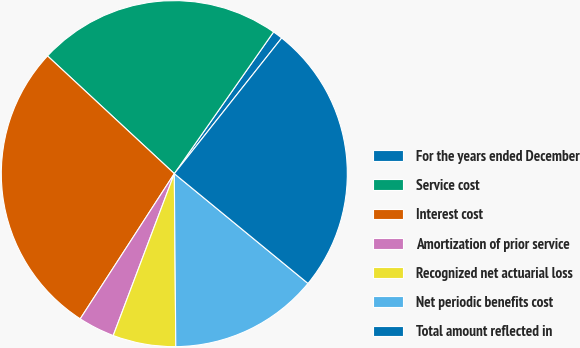<chart> <loc_0><loc_0><loc_500><loc_500><pie_chart><fcel>For the years ended December<fcel>Service cost<fcel>Interest cost<fcel>Amortization of prior service<fcel>Recognized net actuarial loss<fcel>Net periodic benefits cost<fcel>Total amount reflected in<nl><fcel>0.93%<fcel>22.82%<fcel>27.76%<fcel>3.41%<fcel>5.88%<fcel>13.92%<fcel>25.29%<nl></chart> 